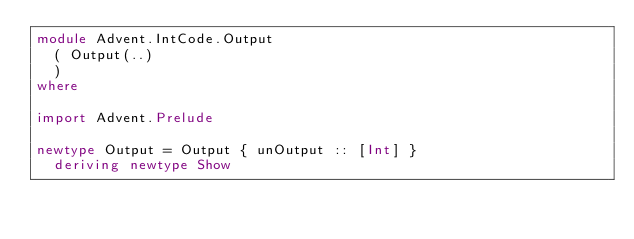Convert code to text. <code><loc_0><loc_0><loc_500><loc_500><_Haskell_>module Advent.IntCode.Output
  ( Output(..)
  )
where

import Advent.Prelude

newtype Output = Output { unOutput :: [Int] }
  deriving newtype Show
</code> 